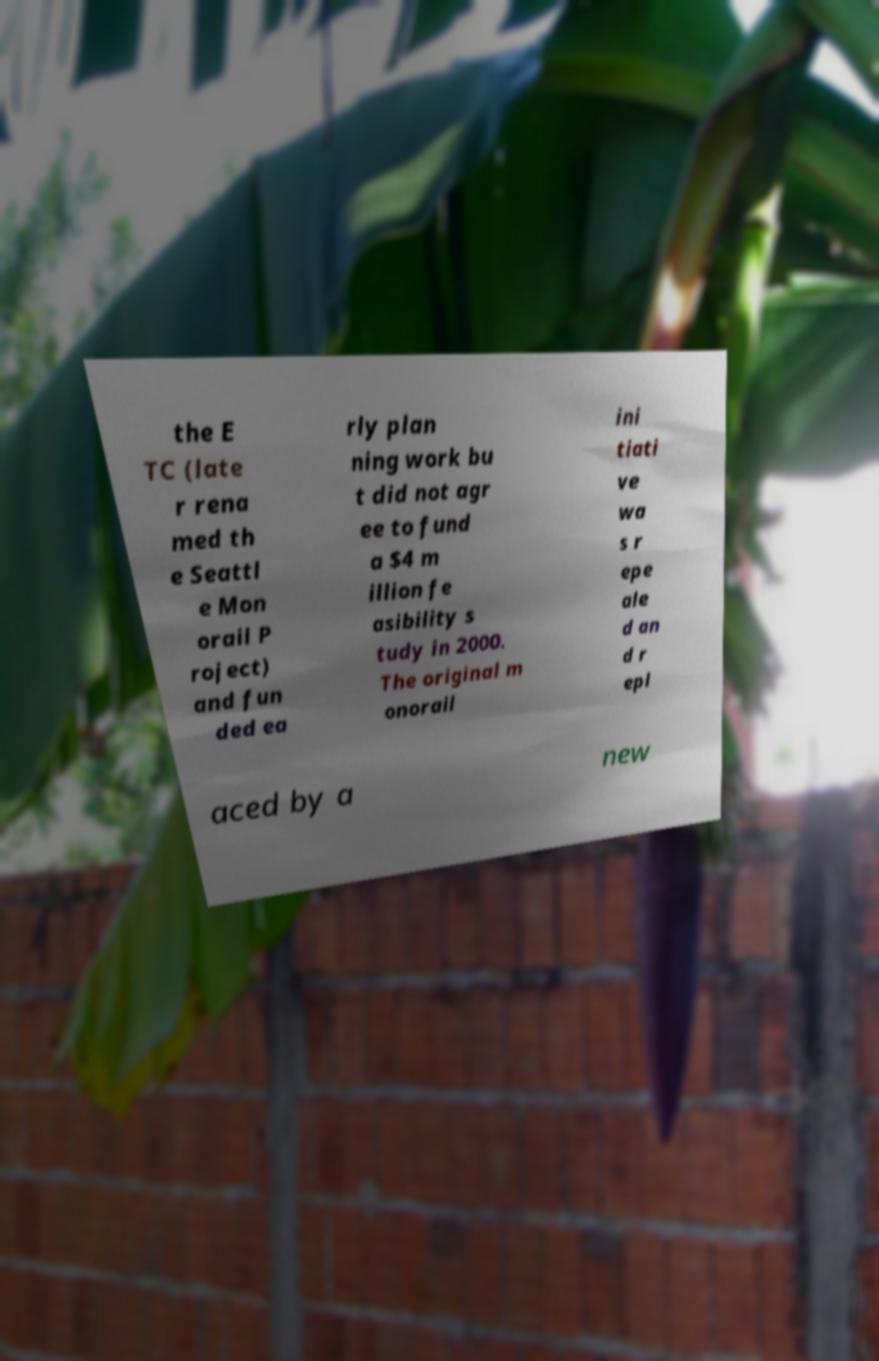I need the written content from this picture converted into text. Can you do that? the E TC (late r rena med th e Seattl e Mon orail P roject) and fun ded ea rly plan ning work bu t did not agr ee to fund a $4 m illion fe asibility s tudy in 2000. The original m onorail ini tiati ve wa s r epe ale d an d r epl aced by a new 